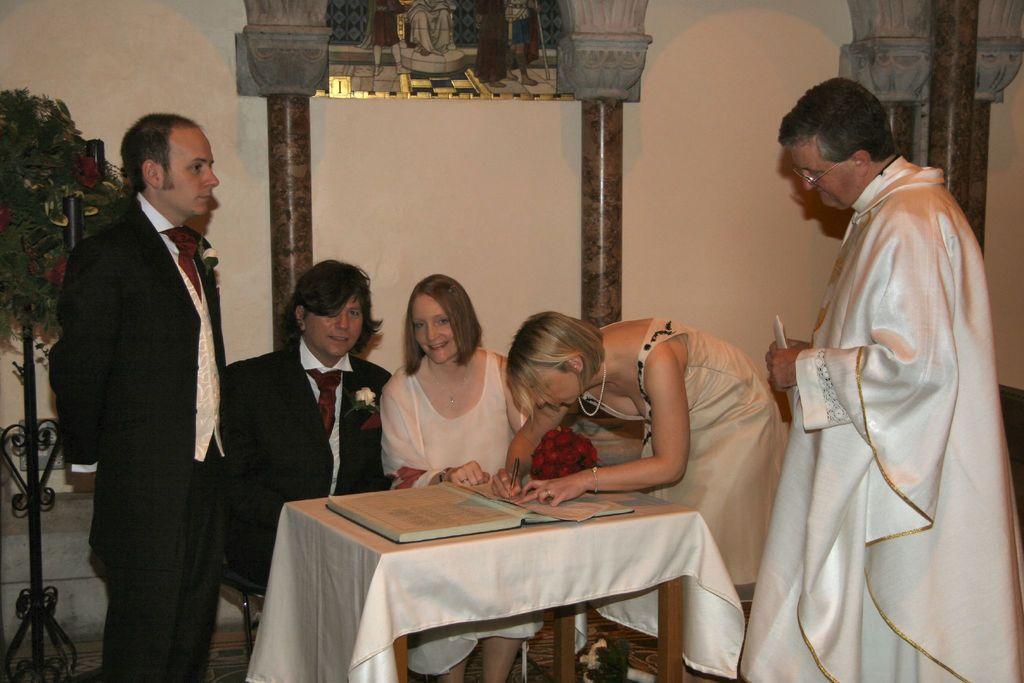How would you summarize this image in a sentence or two? This picture shows a couple seated on the chairs and three people standing and a woman writing on the paper. 